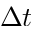<formula> <loc_0><loc_0><loc_500><loc_500>\Delta t</formula> 